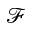Convert formula to latex. <formula><loc_0><loc_0><loc_500><loc_500>\mathcal { F }</formula> 